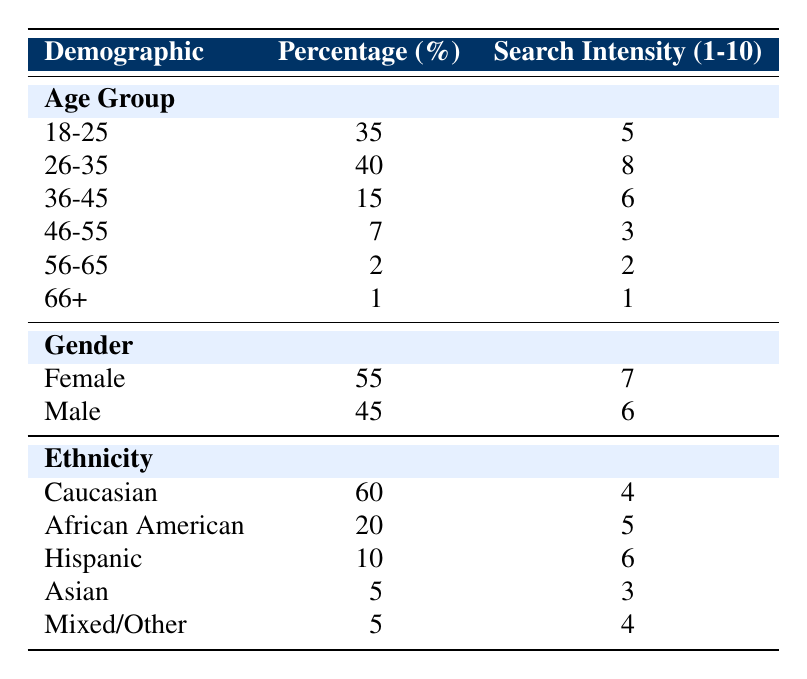What is the percentage of adoptees in the age group 26-35? The table shows that the percentage for the age group 26-35 is listed under the Age Group section, which is 40%.
Answer: 40% What is the search intensity for female adoptees? The table indicates that the search intensity for females, found in the Gender section, is 7.
Answer: 7 How many adoptees in the 36-45 age group exhibit a search intensity higher than 5? The table shows the search intensity for the 36-45 age group is 6. Since there is one group with greater search intensity (26-35) that is at 8, only one group can be counted, which is the 36-45 group.
Answer: 1 What is the average search intensity for all age groups combined? To find this, add the search intensities for each age group: (5 + 8 + 6 + 3 + 2 + 1) = 25. There are six age groups, so the average search intensity is 25/6, which is approximately 4.17.
Answer: 4.17 Is the percentage of Hispanic adoptees greater than 10%? The table lists the percentage for Hispanic adoptees under the Ethnicity section, which is 10%. Since this is equal and not greater, the statement is false.
Answer: No Which age group has the lowest percentage of adoptees? The table indicates that the age group 66+ has the lowest percentage listed under the Age Group section, which is 1%.
Answer: 1% Are there more female adoptees than male adoptees? The table shows that the percentage for female adoptees is 55% while male adoptees account for 45%. Since 55% is greater than 45%, this is true.
Answer: Yes What percentage of adoptees belong to the Caucasian group, and what is their search intensity? The table specifies that the percentage of Caucasian adoptees is 60% and their search intensity is noted as 4 under the Ethnicity section.
Answer: 60% and 4 How does the search intensity for the 26-35 age group compare to that of the 46-55 age group? The table shows the search intensity for the 26-35 age group is 8 while for the 46-55 age group it is 3. Therefore, the search intensity for 26-35 is higher (8 > 3).
Answer: Higher 